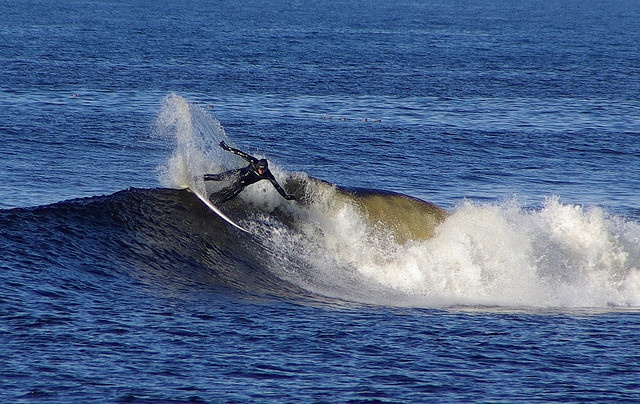Describe the objects in this image and their specific colors. I can see people in gray, black, and darkgray tones and surfboard in gray, ivory, darkgray, and lightgray tones in this image. 